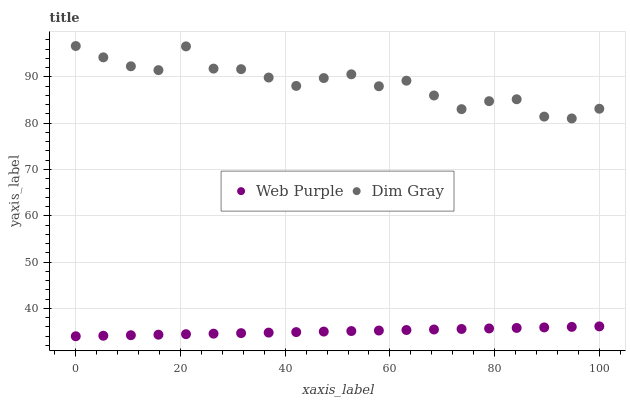Does Web Purple have the minimum area under the curve?
Answer yes or no. Yes. Does Dim Gray have the maximum area under the curve?
Answer yes or no. Yes. Does Dim Gray have the minimum area under the curve?
Answer yes or no. No. Is Web Purple the smoothest?
Answer yes or no. Yes. Is Dim Gray the roughest?
Answer yes or no. Yes. Is Dim Gray the smoothest?
Answer yes or no. No. Does Web Purple have the lowest value?
Answer yes or no. Yes. Does Dim Gray have the lowest value?
Answer yes or no. No. Does Dim Gray have the highest value?
Answer yes or no. Yes. Is Web Purple less than Dim Gray?
Answer yes or no. Yes. Is Dim Gray greater than Web Purple?
Answer yes or no. Yes. Does Web Purple intersect Dim Gray?
Answer yes or no. No. 